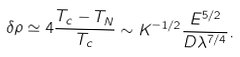<formula> <loc_0><loc_0><loc_500><loc_500>\delta \rho \simeq 4 \frac { T _ { c } - T _ { N } } { T _ { c } } \sim K ^ { - 1 / 2 } \frac { E ^ { 5 / 2 } } { D \lambda ^ { 7 / 4 } } .</formula> 